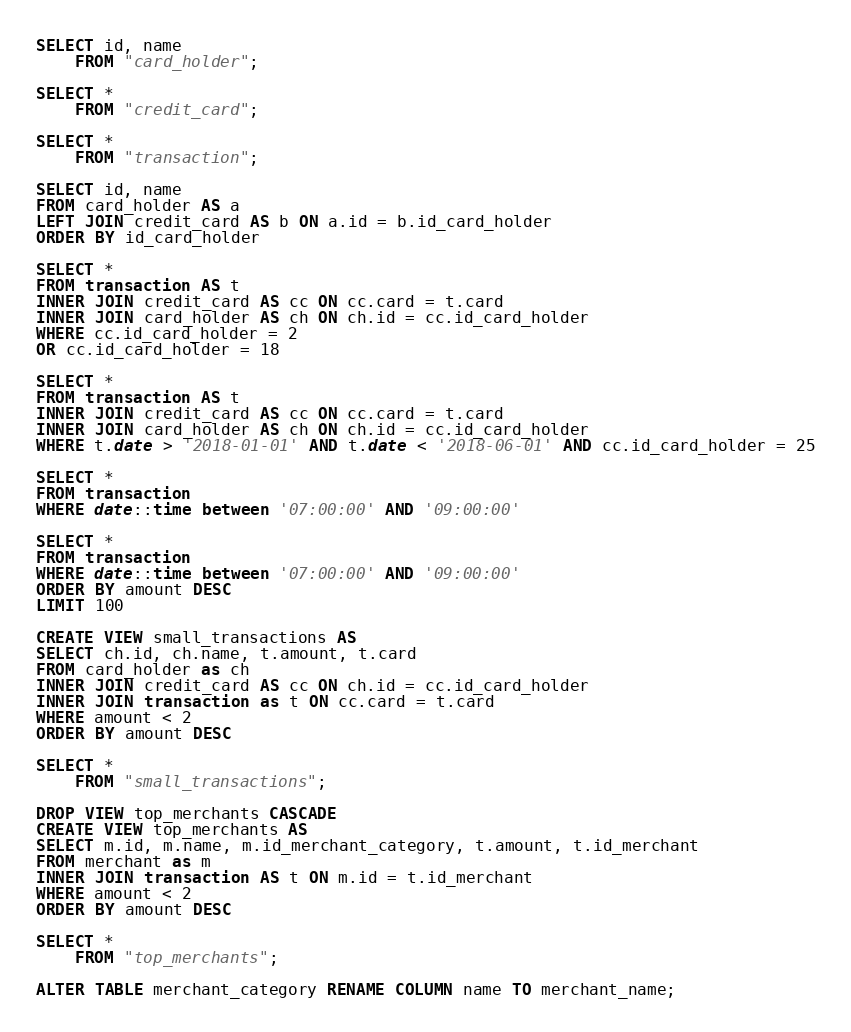Convert code to text. <code><loc_0><loc_0><loc_500><loc_500><_SQL_>SELECT id, name
	FROM "card_holder";
	
SELECT *
	FROM "credit_card";

SELECT *
	FROM "transaction";

SELECT id, name
FROM card_holder AS a
LEFT JOIN credit_card AS b ON a.id = b.id_card_holder
ORDER BY id_card_holder

SELECT *
FROM transaction AS t
INNER JOIN credit_card AS cc ON cc.card = t.card
INNER JOIN card_holder AS ch ON ch.id = cc.id_card_holder
WHERE cc.id_card_holder = 2
OR cc.id_card_holder = 18

SELECT *
FROM transaction AS t
INNER JOIN credit_card AS cc ON cc.card = t.card
INNER JOIN card_holder AS ch ON ch.id = cc.id_card_holder
WHERE t.date > '2018-01-01' AND t.date < '2018-06-01' AND cc.id_card_holder = 25

SELECT *
FROM transaction
WHERE date::time between '07:00:00' AND '09:00:00'

SELECT *
FROM transaction
WHERE date::time between '07:00:00' AND '09:00:00'
ORDER BY amount DESC
LIMIT 100

CREATE VIEW small_transactions AS
SELECT ch.id, ch.name, t.amount, t.card
FROM card_holder as ch
INNER JOIN credit_card AS cc ON ch.id = cc.id_card_holder
INNER JOIN transaction as t ON cc.card = t.card
WHERE amount < 2
ORDER BY amount DESC

SELECT *
	FROM "small_transactions";

DROP VIEW top_merchants CASCADE
CREATE VIEW top_merchants AS
SELECT m.id, m.name, m.id_merchant_category, t.amount, t.id_merchant
FROM merchant as m
INNER JOIN transaction AS t ON m.id = t.id_merchant
WHERE amount < 2
ORDER BY amount DESC

SELECT *
	FROM "top_merchants";

ALTER TABLE merchant_category RENAME COLUMN name TO merchant_name;</code> 